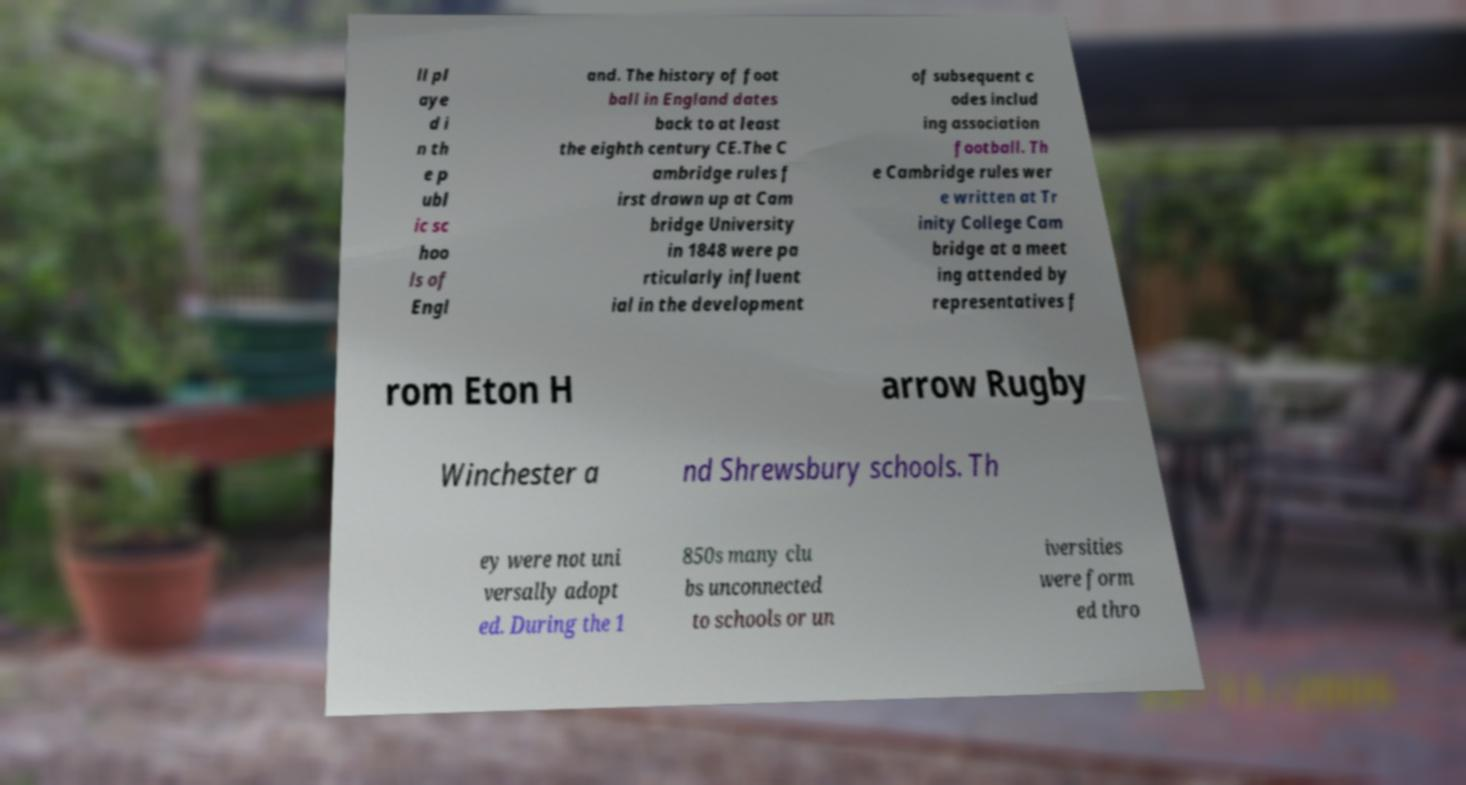For documentation purposes, I need the text within this image transcribed. Could you provide that? ll pl aye d i n th e p ubl ic sc hoo ls of Engl and. The history of foot ball in England dates back to at least the eighth century CE.The C ambridge rules f irst drawn up at Cam bridge University in 1848 were pa rticularly influent ial in the development of subsequent c odes includ ing association football. Th e Cambridge rules wer e written at Tr inity College Cam bridge at a meet ing attended by representatives f rom Eton H arrow Rugby Winchester a nd Shrewsbury schools. Th ey were not uni versally adopt ed. During the 1 850s many clu bs unconnected to schools or un iversities were form ed thro 